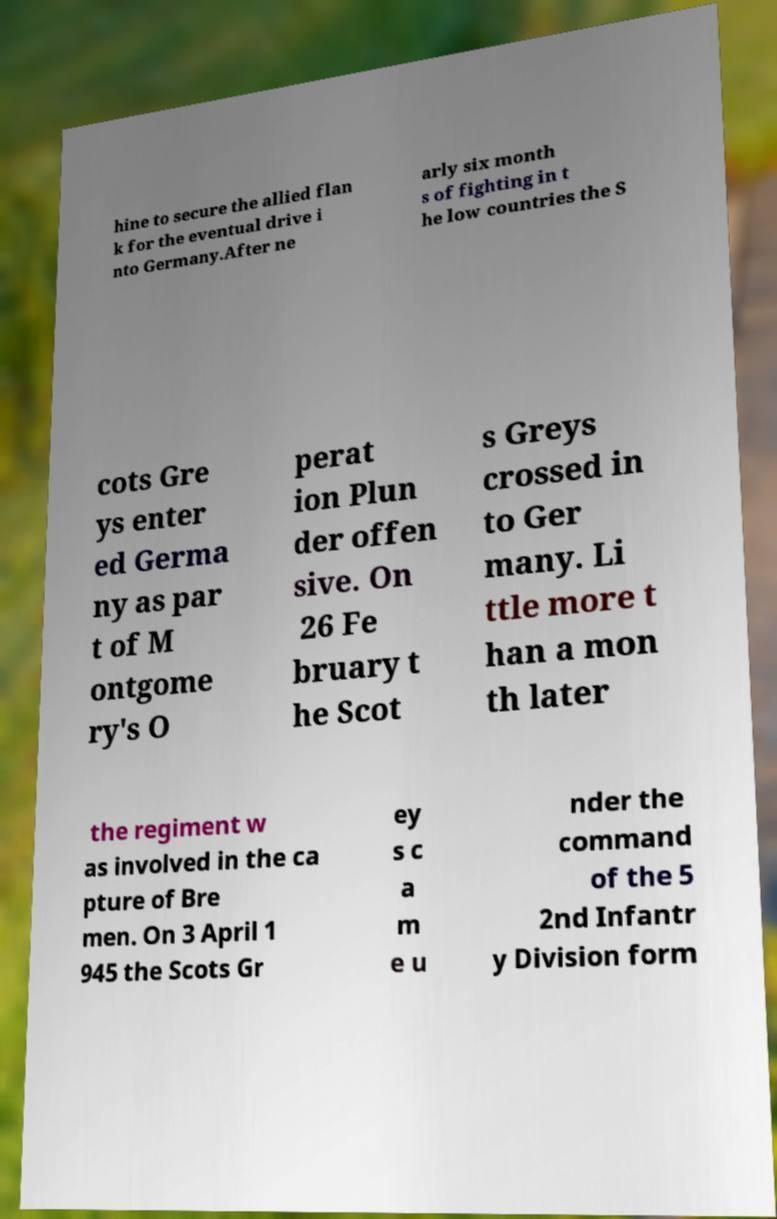Can you accurately transcribe the text from the provided image for me? hine to secure the allied flan k for the eventual drive i nto Germany.After ne arly six month s of fighting in t he low countries the S cots Gre ys enter ed Germa ny as par t of M ontgome ry's O perat ion Plun der offen sive. On 26 Fe bruary t he Scot s Greys crossed in to Ger many. Li ttle more t han a mon th later the regiment w as involved in the ca pture of Bre men. On 3 April 1 945 the Scots Gr ey s c a m e u nder the command of the 5 2nd Infantr y Division form 